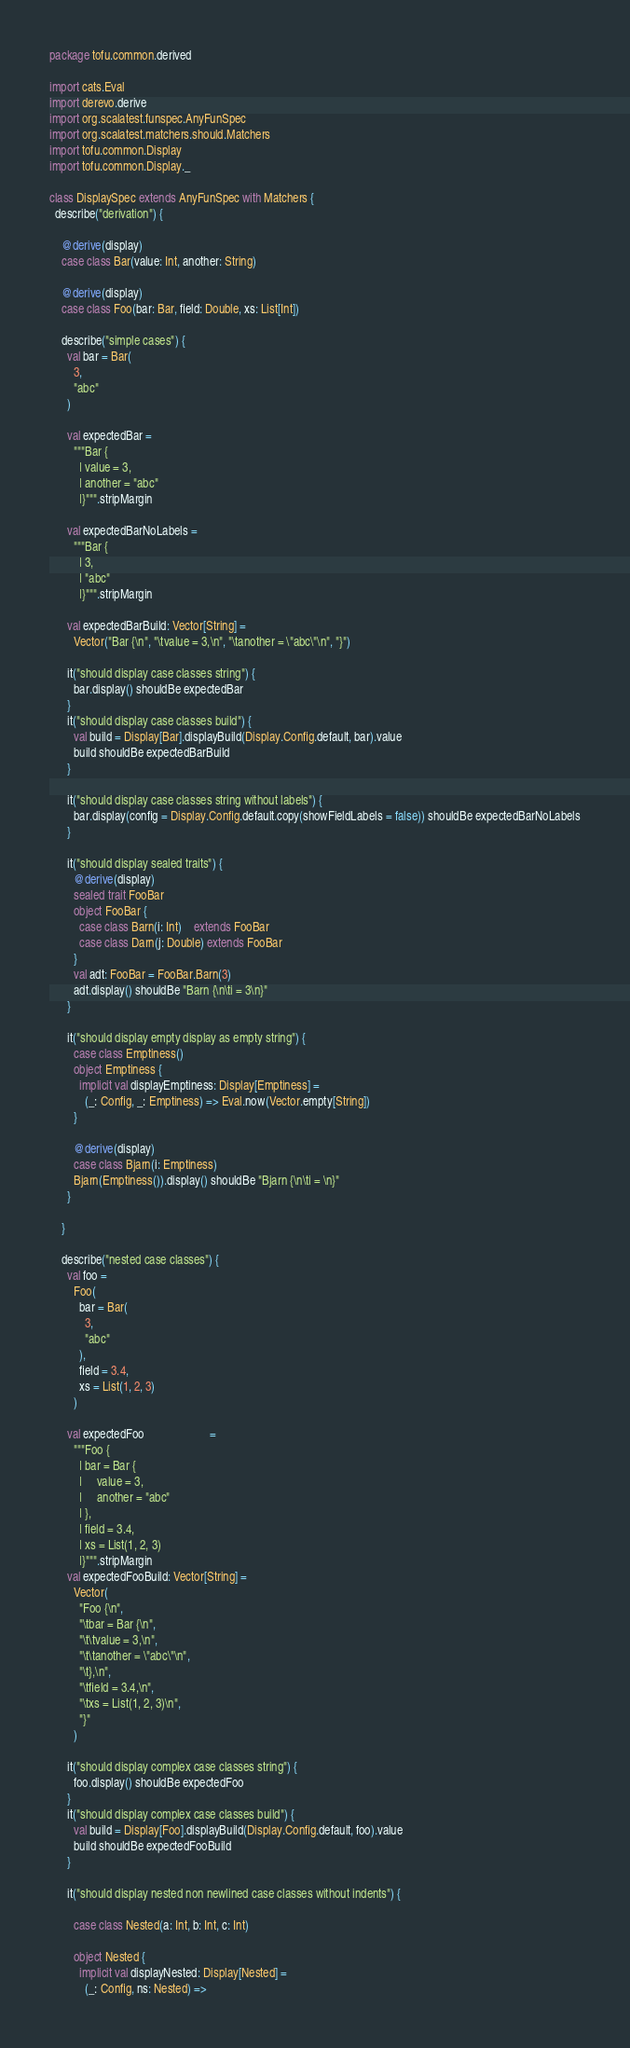<code> <loc_0><loc_0><loc_500><loc_500><_Scala_>package tofu.common.derived

import cats.Eval
import derevo.derive
import org.scalatest.funspec.AnyFunSpec
import org.scalatest.matchers.should.Matchers
import tofu.common.Display
import tofu.common.Display._

class DisplaySpec extends AnyFunSpec with Matchers {
  describe("derivation") {

    @derive(display)
    case class Bar(value: Int, another: String)

    @derive(display)
    case class Foo(bar: Bar, field: Double, xs: List[Int])

    describe("simple cases") {
      val bar = Bar(
        3,
        "abc"
      )

      val expectedBar =
        """Bar {
          |	value = 3,
          |	another = "abc"
          |}""".stripMargin

      val expectedBarNoLabels =
        """Bar {
          |	3,
          |	"abc"
          |}""".stripMargin

      val expectedBarBuild: Vector[String] =
        Vector("Bar {\n", "\tvalue = 3,\n", "\tanother = \"abc\"\n", "}")

      it("should display case classes string") {
        bar.display() shouldBe expectedBar
      }
      it("should display case classes build") {
        val build = Display[Bar].displayBuild(Display.Config.default, bar).value
        build shouldBe expectedBarBuild
      }

      it("should display case classes string without labels") {
        bar.display(config = Display.Config.default.copy(showFieldLabels = false)) shouldBe expectedBarNoLabels
      }

      it("should display sealed traits") {
        @derive(display)
        sealed trait FooBar
        object FooBar {
          case class Barn(i: Int)    extends FooBar
          case class Darn(j: Double) extends FooBar
        }
        val adt: FooBar = FooBar.Barn(3)
        adt.display() shouldBe "Barn {\n\ti = 3\n}"
      }

      it("should display empty display as empty string") {
        case class Emptiness()
        object Emptiness {
          implicit val displayEmptiness: Display[Emptiness] =
            (_: Config, _: Emptiness) => Eval.now(Vector.empty[String])
        }

        @derive(display)
        case class Bjarn(i: Emptiness)
        Bjarn(Emptiness()).display() shouldBe "Bjarn {\n\ti = \n}"
      }

    }

    describe("nested case classes") {
      val foo =
        Foo(
          bar = Bar(
            3,
            "abc"
          ),
          field = 3.4,
          xs = List(1, 2, 3)
        )

      val expectedFoo                      =
        """Foo {
          |	bar = Bar {
          |		value = 3,
          |		another = "abc"
          |	},
          |	field = 3.4,
          |	xs = List(1, 2, 3)
          |}""".stripMargin
      val expectedFooBuild: Vector[String] =
        Vector(
          "Foo {\n",
          "\tbar = Bar {\n",
          "\t\tvalue = 3,\n",
          "\t\tanother = \"abc\"\n",
          "\t},\n",
          "\tfield = 3.4,\n",
          "\txs = List(1, 2, 3)\n",
          "}"
        )

      it("should display complex case classes string") {
        foo.display() shouldBe expectedFoo
      }
      it("should display complex case classes build") {
        val build = Display[Foo].displayBuild(Display.Config.default, foo).value
        build shouldBe expectedFooBuild
      }

      it("should display nested non newlined case classes without indents") {

        case class Nested(a: Int, b: Int, c: Int)

        object Nested {
          implicit val displayNested: Display[Nested] =
            (_: Config, ns: Nested) =></code> 